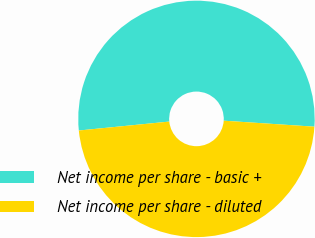Convert chart to OTSL. <chart><loc_0><loc_0><loc_500><loc_500><pie_chart><fcel>Net income per share - basic +<fcel>Net income per share - diluted<nl><fcel>52.62%<fcel>47.38%<nl></chart> 